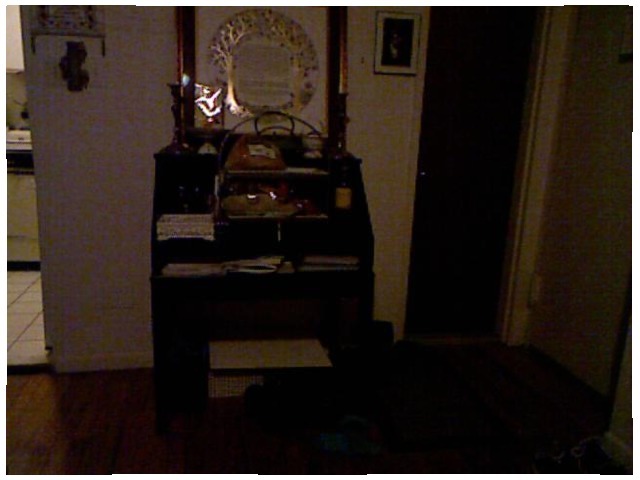<image>
Is there a picture on the wall? Yes. Looking at the image, I can see the picture is positioned on top of the wall, with the wall providing support. Is there a tree on the wall? Yes. Looking at the image, I can see the tree is positioned on top of the wall, with the wall providing support. Is the door to the right of the photo frame? Yes. From this viewpoint, the door is positioned to the right side relative to the photo frame. 